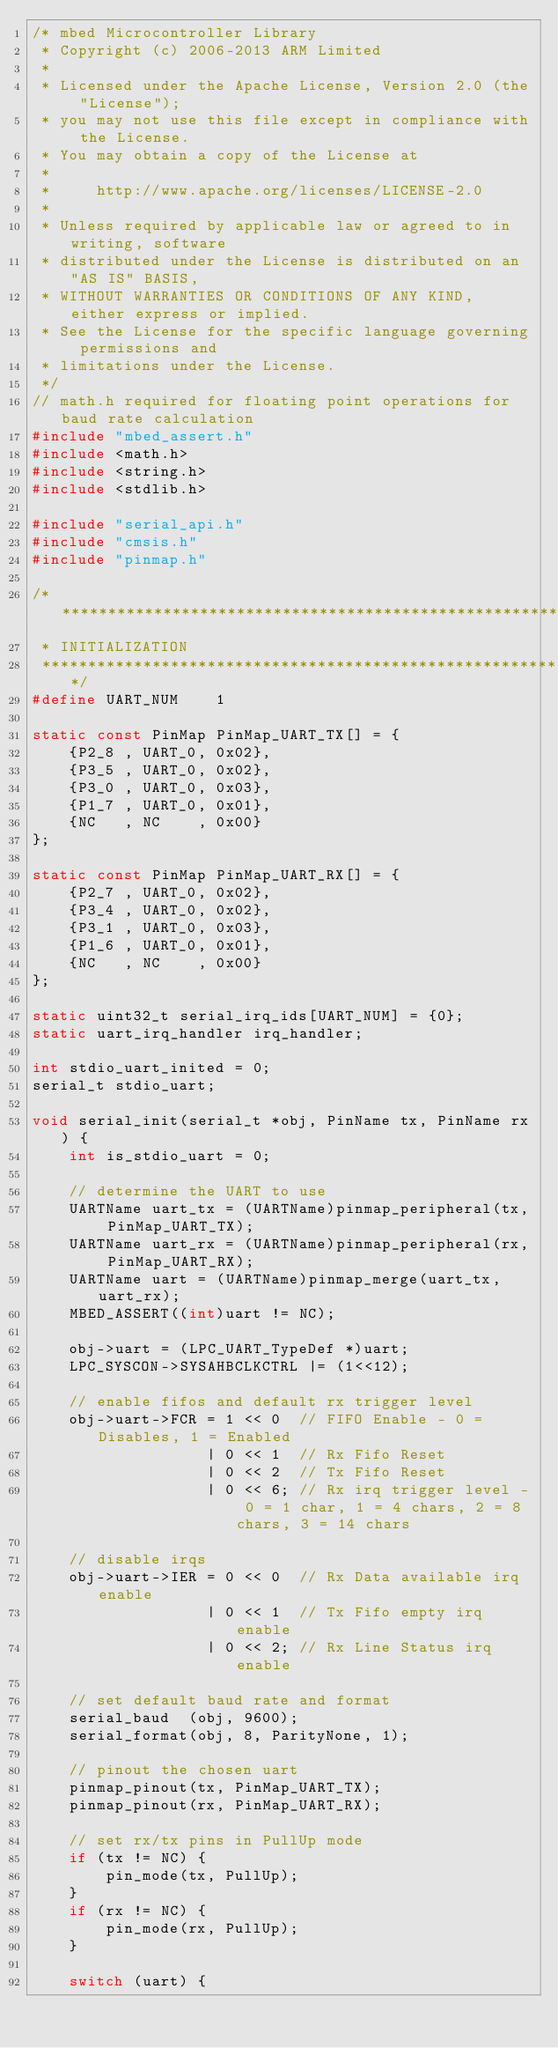Convert code to text. <code><loc_0><loc_0><loc_500><loc_500><_C_>/* mbed Microcontroller Library
 * Copyright (c) 2006-2013 ARM Limited
 *
 * Licensed under the Apache License, Version 2.0 (the "License");
 * you may not use this file except in compliance with the License.
 * You may obtain a copy of the License at
 *
 *     http://www.apache.org/licenses/LICENSE-2.0
 *
 * Unless required by applicable law or agreed to in writing, software
 * distributed under the License is distributed on an "AS IS" BASIS,
 * WITHOUT WARRANTIES OR CONDITIONS OF ANY KIND, either express or implied.
 * See the License for the specific language governing permissions and
 * limitations under the License.
 */
// math.h required for floating point operations for baud rate calculation
#include "mbed_assert.h"
#include <math.h>
#include <string.h>
#include <stdlib.h>

#include "serial_api.h"
#include "cmsis.h"
#include "pinmap.h"

/******************************************************************************
 * INITIALIZATION
 ******************************************************************************/
#define UART_NUM    1

static const PinMap PinMap_UART_TX[] = {
    {P2_8 , UART_0, 0x02},
    {P3_5 , UART_0, 0x02},
    {P3_0 , UART_0, 0x03},
    {P1_7 , UART_0, 0x01},
    {NC   , NC    , 0x00}
};

static const PinMap PinMap_UART_RX[] = {
    {P2_7 , UART_0, 0x02},
    {P3_4 , UART_0, 0x02},
    {P3_1 , UART_0, 0x03},
    {P1_6 , UART_0, 0x01},
    {NC   , NC    , 0x00}
};

static uint32_t serial_irq_ids[UART_NUM] = {0};
static uart_irq_handler irq_handler;

int stdio_uart_inited = 0;
serial_t stdio_uart;

void serial_init(serial_t *obj, PinName tx, PinName rx) {
    int is_stdio_uart = 0;
    
    // determine the UART to use
    UARTName uart_tx = (UARTName)pinmap_peripheral(tx, PinMap_UART_TX);
    UARTName uart_rx = (UARTName)pinmap_peripheral(rx, PinMap_UART_RX);
    UARTName uart = (UARTName)pinmap_merge(uart_tx, uart_rx);
    MBED_ASSERT((int)uart != NC);
    
    obj->uart = (LPC_UART_TypeDef *)uart;
    LPC_SYSCON->SYSAHBCLKCTRL |= (1<<12);
    
    // enable fifos and default rx trigger level
    obj->uart->FCR = 1 << 0  // FIFO Enable - 0 = Disables, 1 = Enabled
                   | 0 << 1  // Rx Fifo Reset
                   | 0 << 2  // Tx Fifo Reset
                   | 0 << 6; // Rx irq trigger level - 0 = 1 char, 1 = 4 chars, 2 = 8 chars, 3 = 14 chars
    
    // disable irqs
    obj->uart->IER = 0 << 0  // Rx Data available irq enable
                   | 0 << 1  // Tx Fifo empty irq enable
                   | 0 << 2; // Rx Line Status irq enable
    
    // set default baud rate and format
    serial_baud  (obj, 9600);
    serial_format(obj, 8, ParityNone, 1);
    
    // pinout the chosen uart
    pinmap_pinout(tx, PinMap_UART_TX);
    pinmap_pinout(rx, PinMap_UART_RX);
    
    // set rx/tx pins in PullUp mode
    if (tx != NC) {
        pin_mode(tx, PullUp);
    }
    if (rx != NC) {
        pin_mode(rx, PullUp);
    }
    
    switch (uart) {</code> 